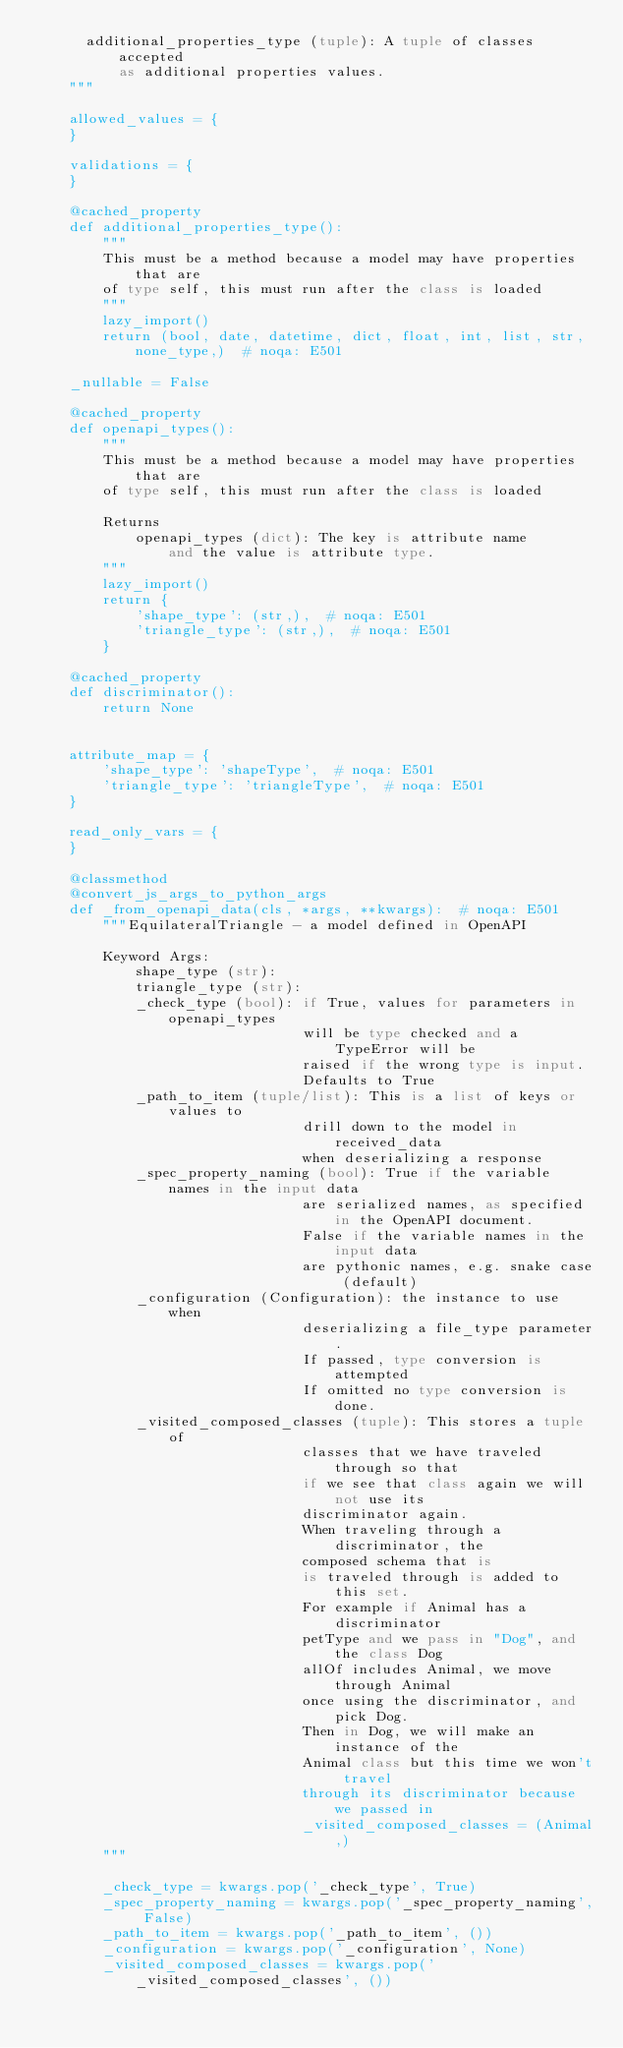<code> <loc_0><loc_0><loc_500><loc_500><_Python_>      additional_properties_type (tuple): A tuple of classes accepted
          as additional properties values.
    """

    allowed_values = {
    }

    validations = {
    }

    @cached_property
    def additional_properties_type():
        """
        This must be a method because a model may have properties that are
        of type self, this must run after the class is loaded
        """
        lazy_import()
        return (bool, date, datetime, dict, float, int, list, str, none_type,)  # noqa: E501

    _nullable = False

    @cached_property
    def openapi_types():
        """
        This must be a method because a model may have properties that are
        of type self, this must run after the class is loaded

        Returns
            openapi_types (dict): The key is attribute name
                and the value is attribute type.
        """
        lazy_import()
        return {
            'shape_type': (str,),  # noqa: E501
            'triangle_type': (str,),  # noqa: E501
        }

    @cached_property
    def discriminator():
        return None


    attribute_map = {
        'shape_type': 'shapeType',  # noqa: E501
        'triangle_type': 'triangleType',  # noqa: E501
    }

    read_only_vars = {
    }

    @classmethod
    @convert_js_args_to_python_args
    def _from_openapi_data(cls, *args, **kwargs):  # noqa: E501
        """EquilateralTriangle - a model defined in OpenAPI

        Keyword Args:
            shape_type (str):
            triangle_type (str):
            _check_type (bool): if True, values for parameters in openapi_types
                                will be type checked and a TypeError will be
                                raised if the wrong type is input.
                                Defaults to True
            _path_to_item (tuple/list): This is a list of keys or values to
                                drill down to the model in received_data
                                when deserializing a response
            _spec_property_naming (bool): True if the variable names in the input data
                                are serialized names, as specified in the OpenAPI document.
                                False if the variable names in the input data
                                are pythonic names, e.g. snake case (default)
            _configuration (Configuration): the instance to use when
                                deserializing a file_type parameter.
                                If passed, type conversion is attempted
                                If omitted no type conversion is done.
            _visited_composed_classes (tuple): This stores a tuple of
                                classes that we have traveled through so that
                                if we see that class again we will not use its
                                discriminator again.
                                When traveling through a discriminator, the
                                composed schema that is
                                is traveled through is added to this set.
                                For example if Animal has a discriminator
                                petType and we pass in "Dog", and the class Dog
                                allOf includes Animal, we move through Animal
                                once using the discriminator, and pick Dog.
                                Then in Dog, we will make an instance of the
                                Animal class but this time we won't travel
                                through its discriminator because we passed in
                                _visited_composed_classes = (Animal,)
        """

        _check_type = kwargs.pop('_check_type', True)
        _spec_property_naming = kwargs.pop('_spec_property_naming', False)
        _path_to_item = kwargs.pop('_path_to_item', ())
        _configuration = kwargs.pop('_configuration', None)
        _visited_composed_classes = kwargs.pop('_visited_composed_classes', ())
</code> 